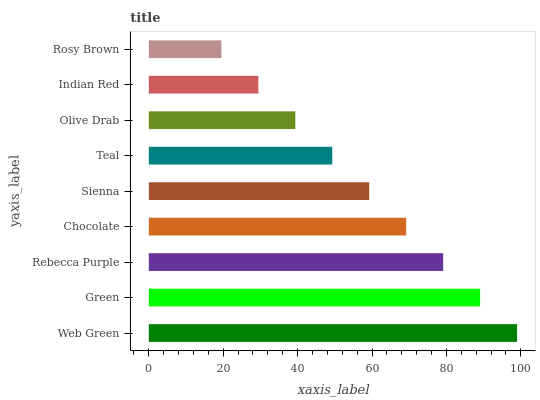Is Rosy Brown the minimum?
Answer yes or no. Yes. Is Web Green the maximum?
Answer yes or no. Yes. Is Green the minimum?
Answer yes or no. No. Is Green the maximum?
Answer yes or no. No. Is Web Green greater than Green?
Answer yes or no. Yes. Is Green less than Web Green?
Answer yes or no. Yes. Is Green greater than Web Green?
Answer yes or no. No. Is Web Green less than Green?
Answer yes or no. No. Is Sienna the high median?
Answer yes or no. Yes. Is Sienna the low median?
Answer yes or no. Yes. Is Chocolate the high median?
Answer yes or no. No. Is Olive Drab the low median?
Answer yes or no. No. 